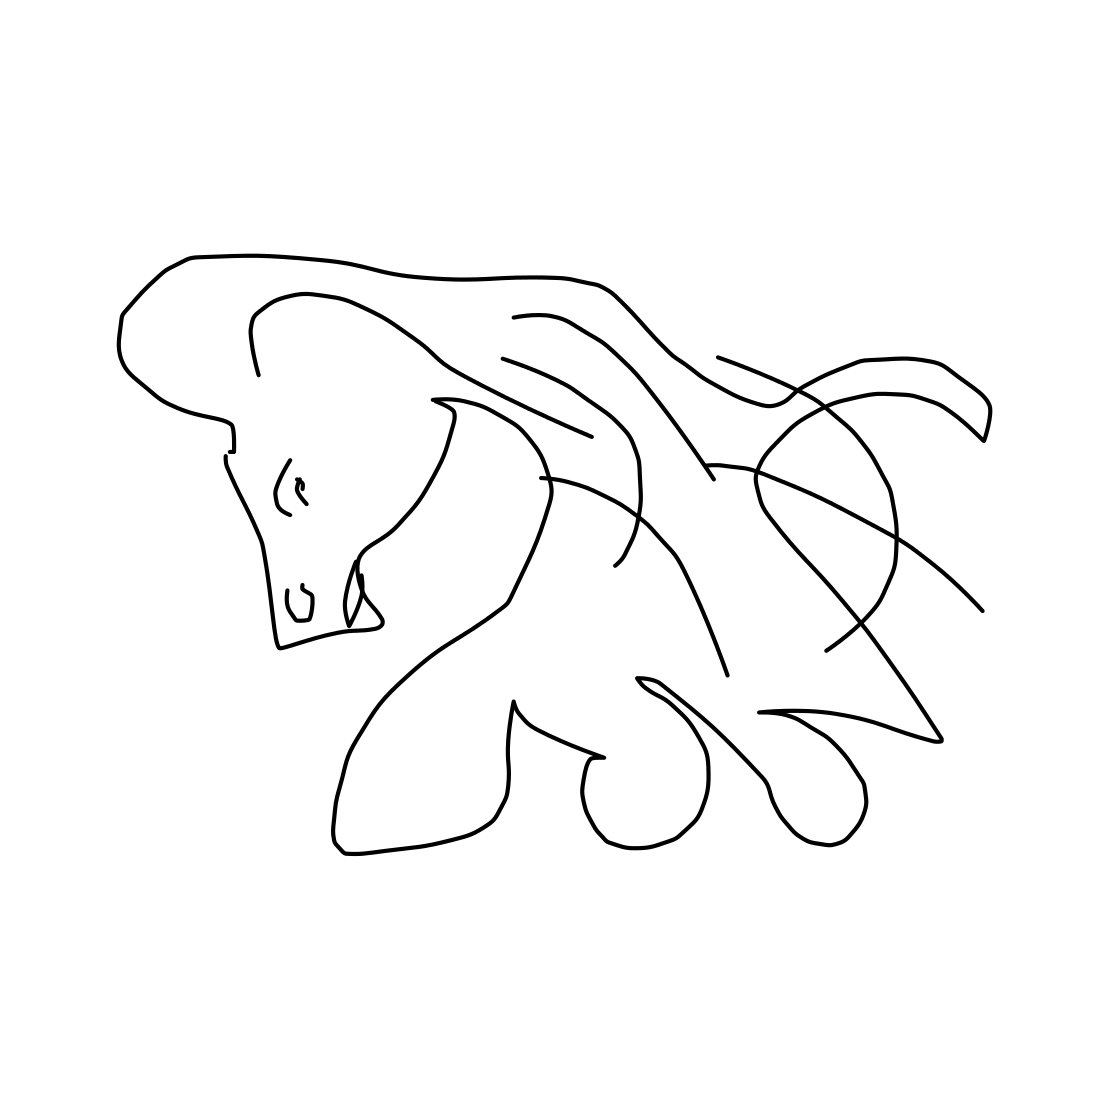Can you describe the style of the artwork? The style of the artwork is minimalist and abstract, using continuous lines to form a graceful depiction of a horse without any intricate detailing, which gives it a modern and elegant visual appeal. 